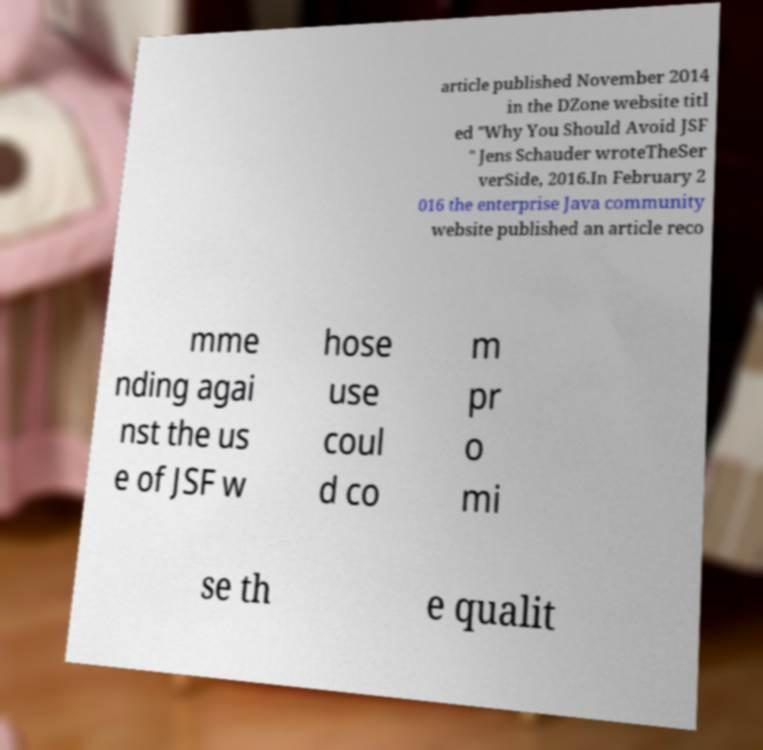For documentation purposes, I need the text within this image transcribed. Could you provide that? article published November 2014 in the DZone website titl ed "Why You Should Avoid JSF " Jens Schauder wroteTheSer verSide, 2016.In February 2 016 the enterprise Java community website published an article reco mme nding agai nst the us e of JSF w hose use coul d co m pr o mi se th e qualit 